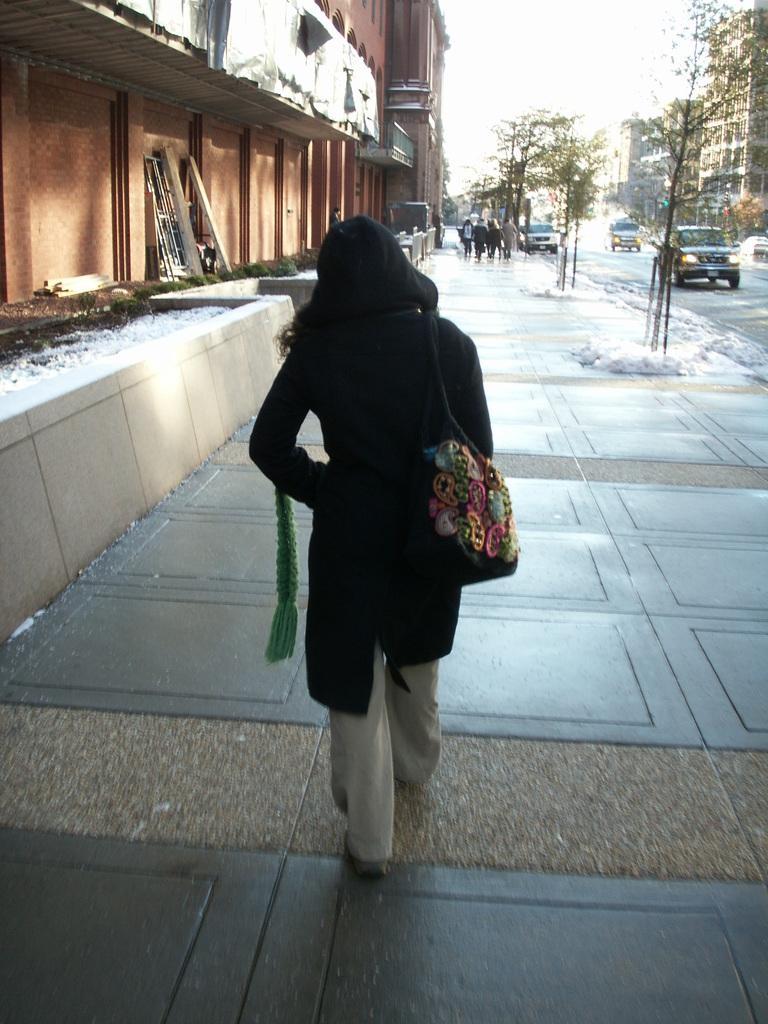Please provide a concise description of this image. In this picture I can see a person walking in the middle, on the left side there are buildings, in the background few vehicles are moving on the road and there are trees, at the top there is the sky. 